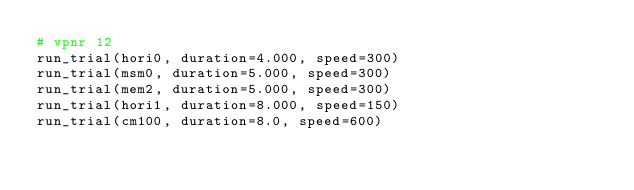<code> <loc_0><loc_0><loc_500><loc_500><_Python_># vpnr 12
run_trial(hori0, duration=4.000, speed=300)
run_trial(msm0, duration=5.000, speed=300)
run_trial(mem2, duration=5.000, speed=300)
run_trial(hori1, duration=8.000, speed=150)
run_trial(cm100, duration=8.0, speed=600)</code> 